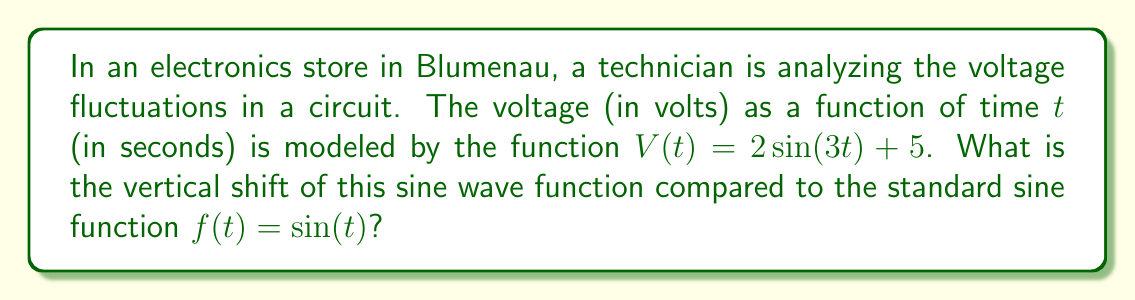What is the answer to this math problem? Let's approach this step-by-step:

1) The general form of a transformed sine function is:
   $$ f(t) = A\sin(B(t-C)) + D $$
   where $D$ represents the vertical shift.

2) In our case, we have:
   $$ V(t) = 2\sin(3t) + 5 $$

3) Comparing this to the general form, we can identify that:
   - $A = 2$ (amplitude)
   - $B = 3$ (frequency)
   - $C = 0$ (horizontal shift)
   - $D = 5$ (vertical shift)

4) The vertical shift is the value that's added to or subtracted from the entire function, shifting it up or down on the coordinate plane.

5) In this case, the +5 at the end of the function $V(t) = 2\sin(3t) + 5$ indicates that the entire sine wave is shifted 5 units upward compared to the standard sine function.

Therefore, the vertical shift of this sine wave function is 5 units upward.
Answer: 5 units upward 